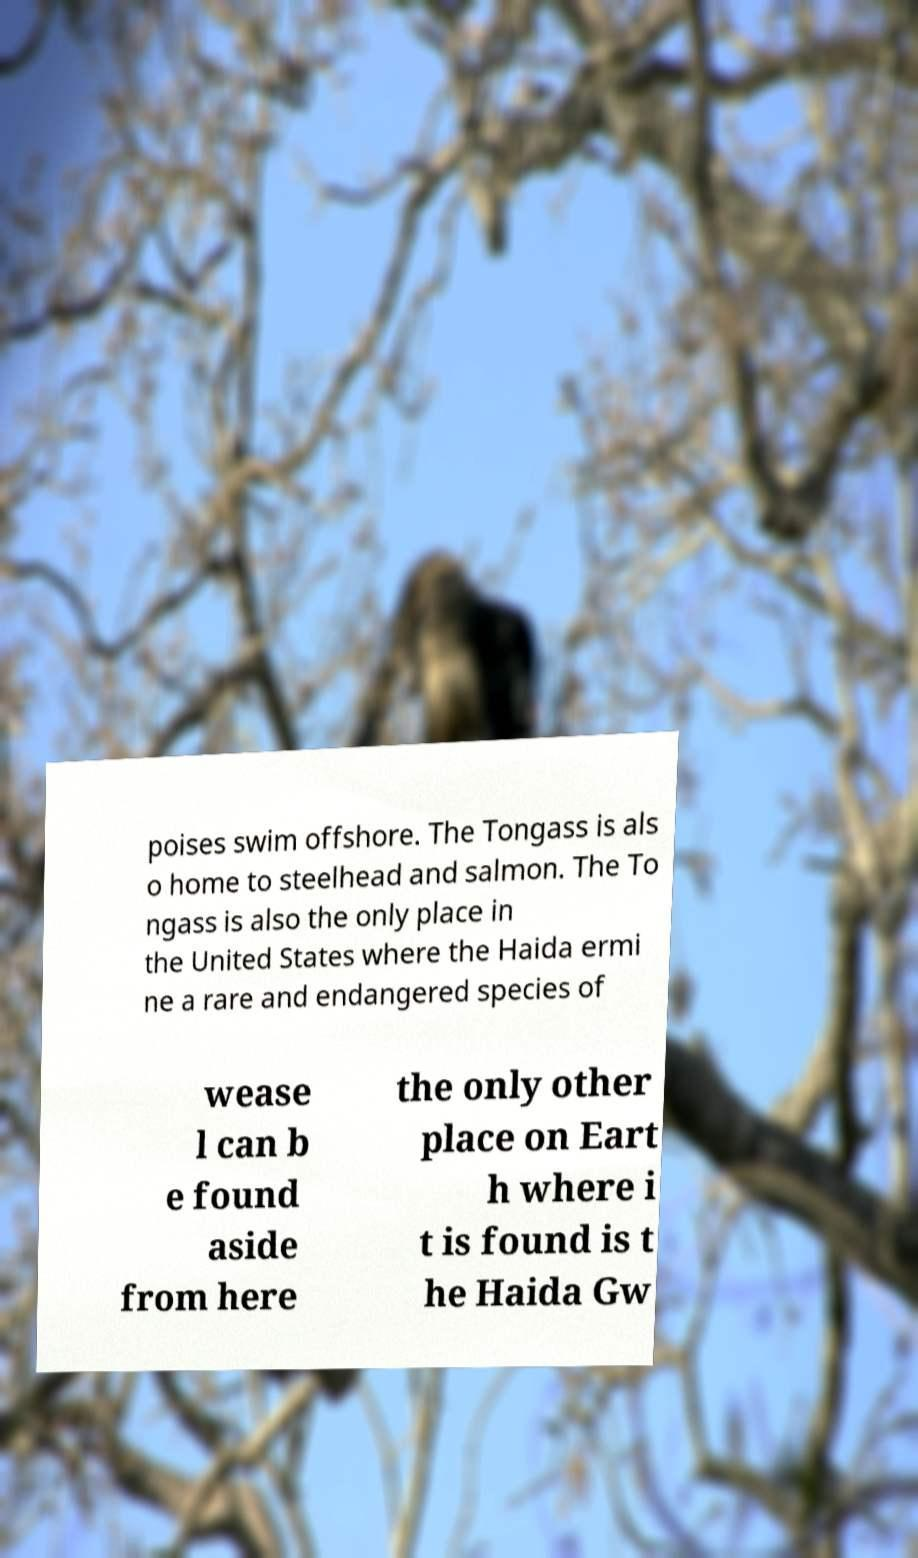For documentation purposes, I need the text within this image transcribed. Could you provide that? poises swim offshore. The Tongass is als o home to steelhead and salmon. The To ngass is also the only place in the United States where the Haida ermi ne a rare and endangered species of wease l can b e found aside from here the only other place on Eart h where i t is found is t he Haida Gw 